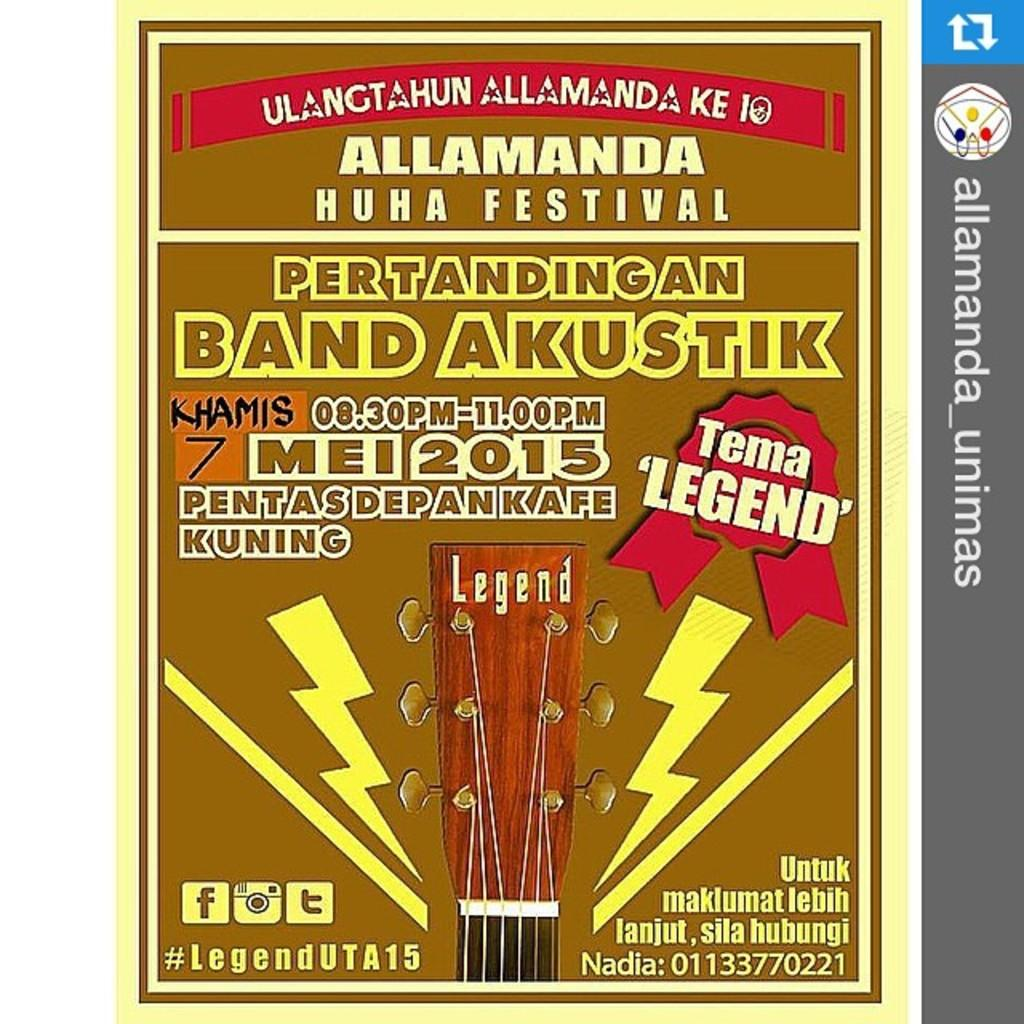Provide a one-sentence caption for the provided image. A brown poster that reads Allamanda Huhu Festival featuring Pertandingan Band Akustik with a guitar end displayed. 